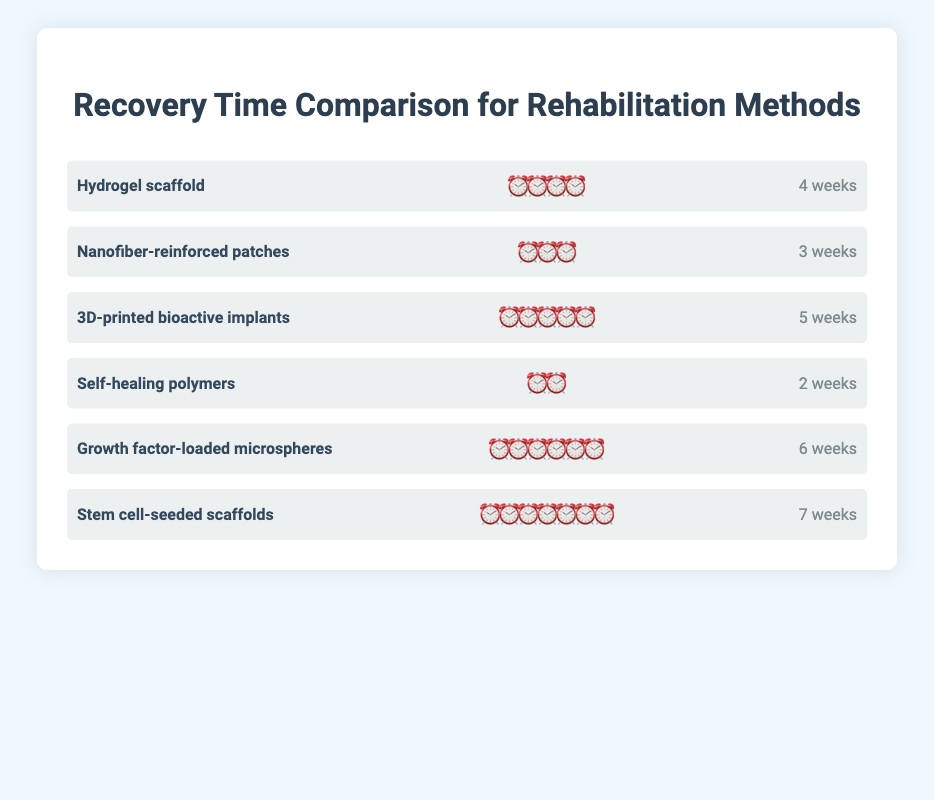what is the rehabilitation method with the shortest recovery time? The self-healing polymers method has the shortest recovery time represented by two clock emojis (⏰⏰), which is equivalent to 2 weeks.
Answer: Self-healing polymers which rehabilitation method has the longest recovery time? The stem cell-seeded scaffolds method has the longest recovery time represented by seven clock emojis (⏰⏰⏰⏰⏰⏰⏰), which is equivalent to 7 weeks.
Answer: Stem cell-seeded scaffolds how many rehabilitation methods have a recovery time of 4 weeks or less? The methods with recovery times of 4 weeks or less are "Hydrogel scaffold" (4 weeks), "Nanofiber-reinforced patches" (3 weeks), and "Self-healing polymers" (2 weeks). Thus, there are 3 methods.
Answer: 3 compare the recovery time between nanofiber-reinforced patches and 3d-printed bioactive implants. which is shorter? The nanofiber-reinforced patches have a recovery time represented by three clock emojis (⏰⏰⏰), which is equivalent to 3 weeks. The 3D-printed bioactive implants have a recovery time represented by five clock emojis (⏰⏰⏰⏰⏰), which is equivalent to 5 weeks. So, nanofiber-reinforced patches have a shorter recovery time.
Answer: Nanofiber-reinforced patches calculate the average recovery time for all rehabilitation methods. The recovery times are 4, 3, 5, 2, 6, and 7 weeks. Sum these times: 4 + 3 + 5 + 2 + 6 + 7 = 27 weeks. There are 6 methods, so the average recovery time is 27 weeks / 6 methods = 4.5 weeks.
Answer: 4.5 weeks rank the rehabilitation methods from shortest to longest recovery time. The methods ranked from shortest to longest recovery time are:
1. Self-healing polymers (2 weeks)
2. Nanofiber-reinforced patches (3 weeks)
3. Hydrogel scaffold (4 weeks)
4. 3D-printed bioactive implants (5 weeks)
5. Growth factor-loaded microspheres (6 weeks)
6. Stem cell-seeded scaffolds (7 weeks)
Answer: Self-healing polymers, Nanofiber-reinforced patches, Hydrogel scaffold, 3D-printed bioactive implants, Growth factor-loaded microspheres, Stem cell-seeded scaffolds which methods have a recovery time longer than hydrogel scaffold? The hydrogel scaffold method has a recovery time of 4 weeks. The methods with recovery times longer than 4 weeks are "3D-printed bioactive implants" (5 weeks), "Growth factor-loaded microspheres" (6 weeks), and "Stem cell-seeded scaffolds" (7 weeks).
Answer: 3D-printed bioactive implants, Growth factor-loaded microspheres, Stem cell-seeded scaffolds 